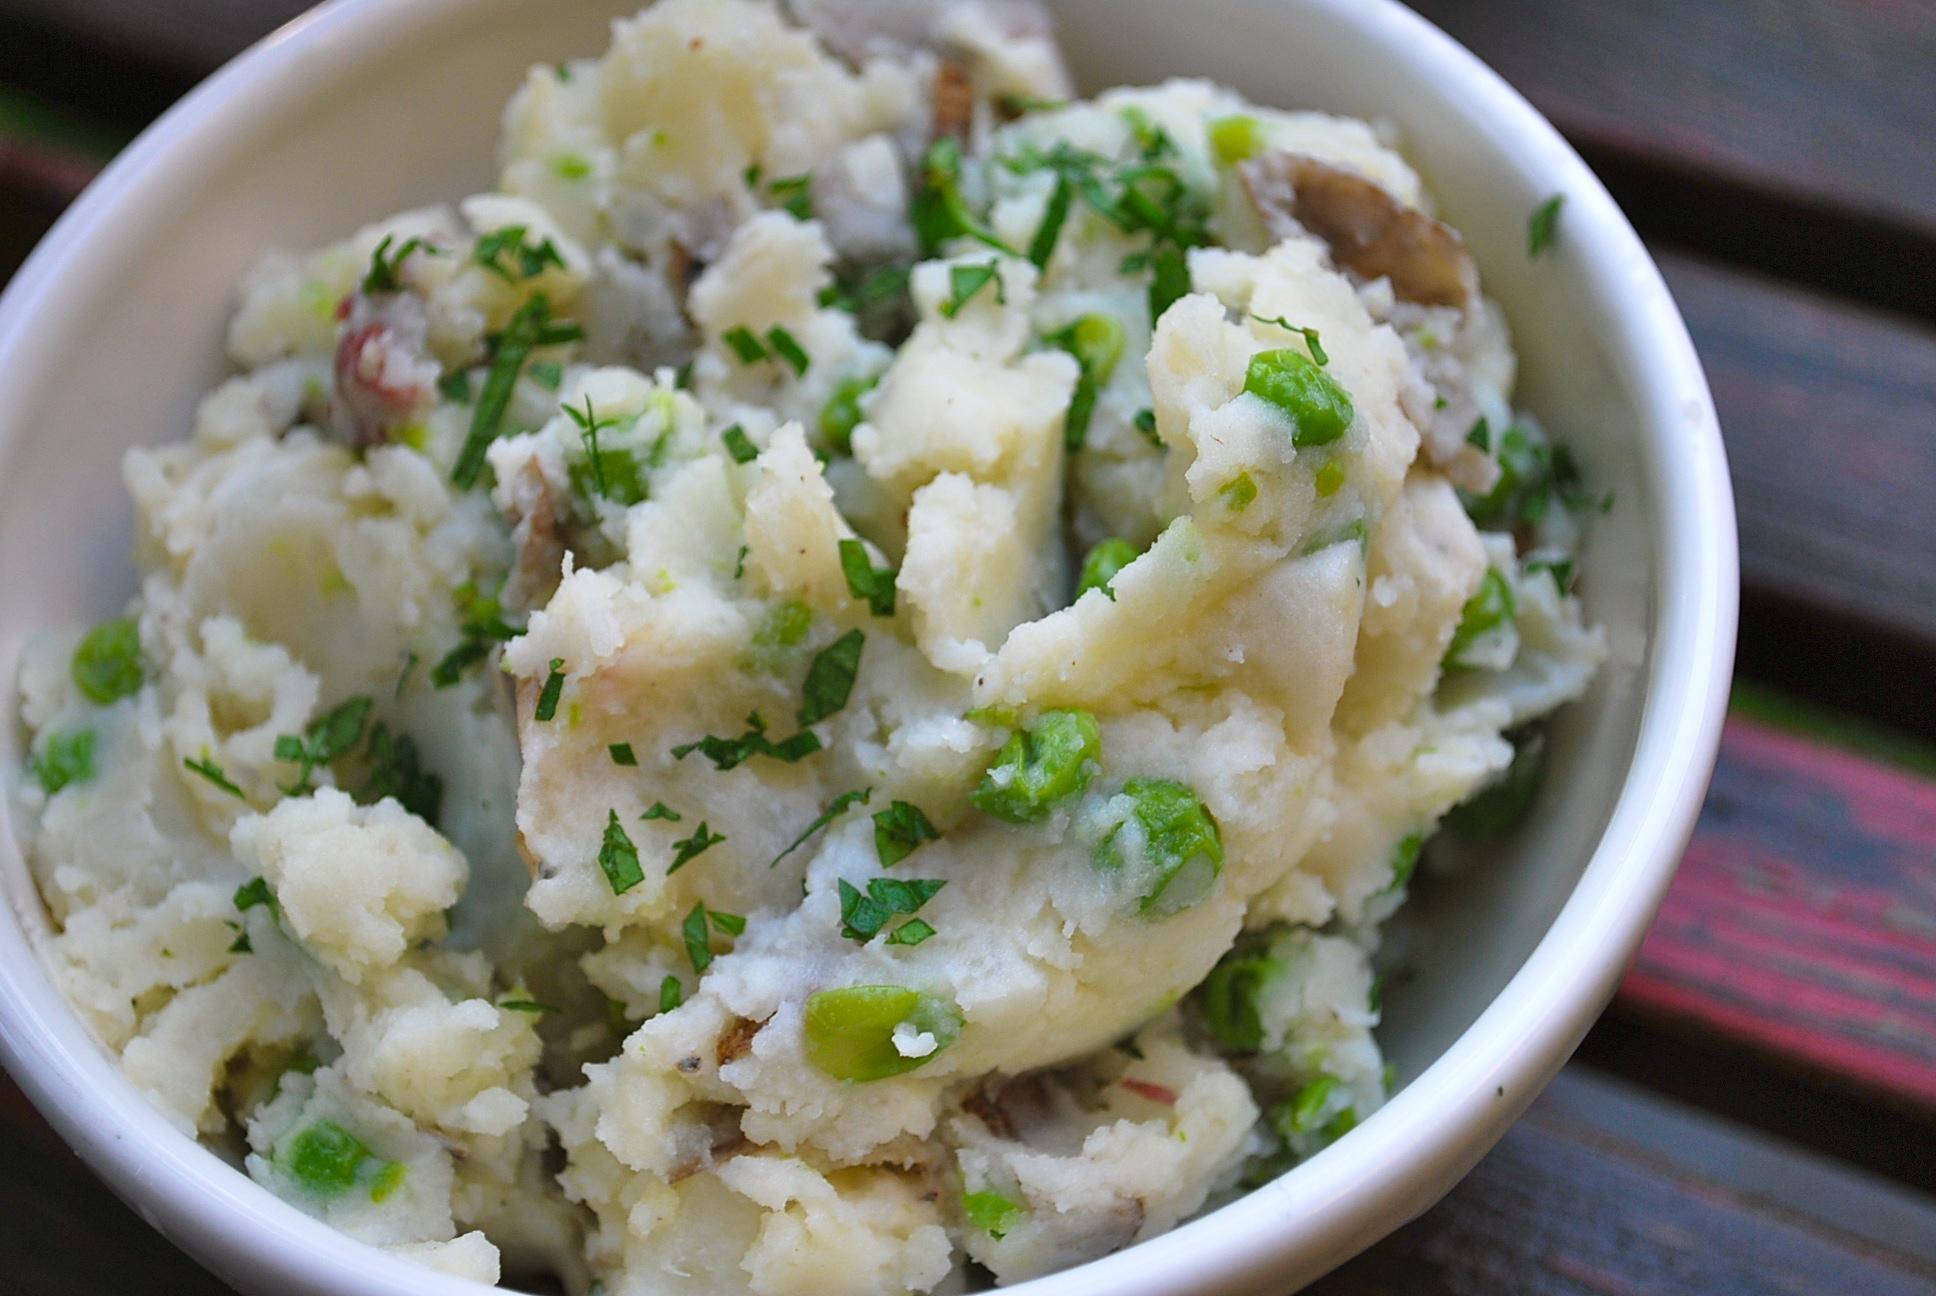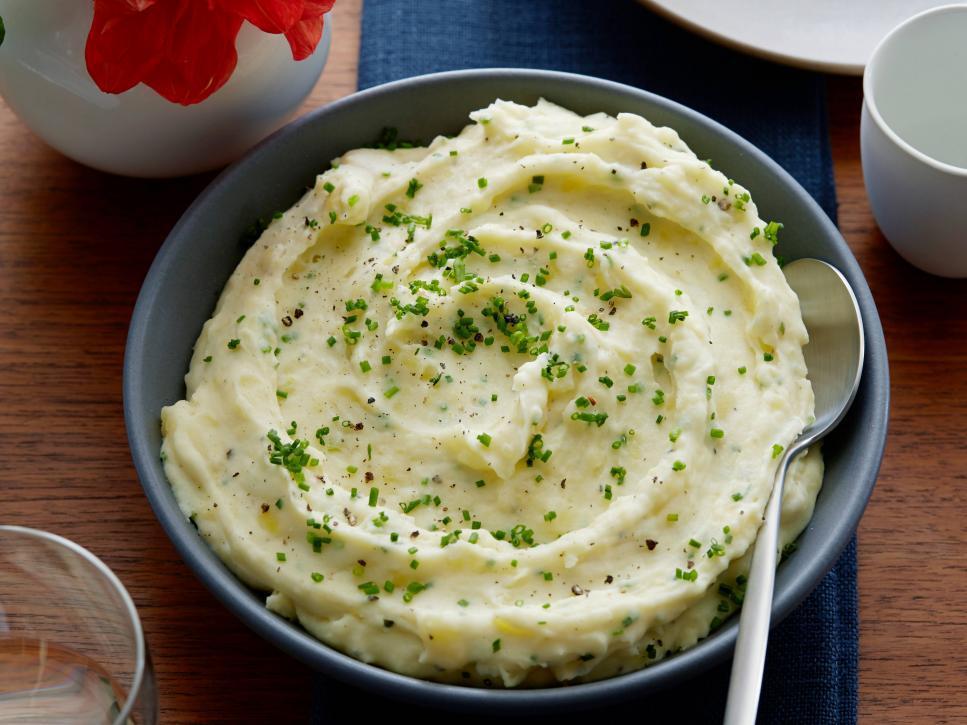The first image is the image on the left, the second image is the image on the right. For the images displayed, is the sentence "There is a utensil adjacent to the mashed potatoes." factually correct? Answer yes or no. Yes. The first image is the image on the left, the second image is the image on the right. For the images shown, is this caption "One piece of silverware is in a dish that contains something resembling mashed potatoes." true? Answer yes or no. Yes. 